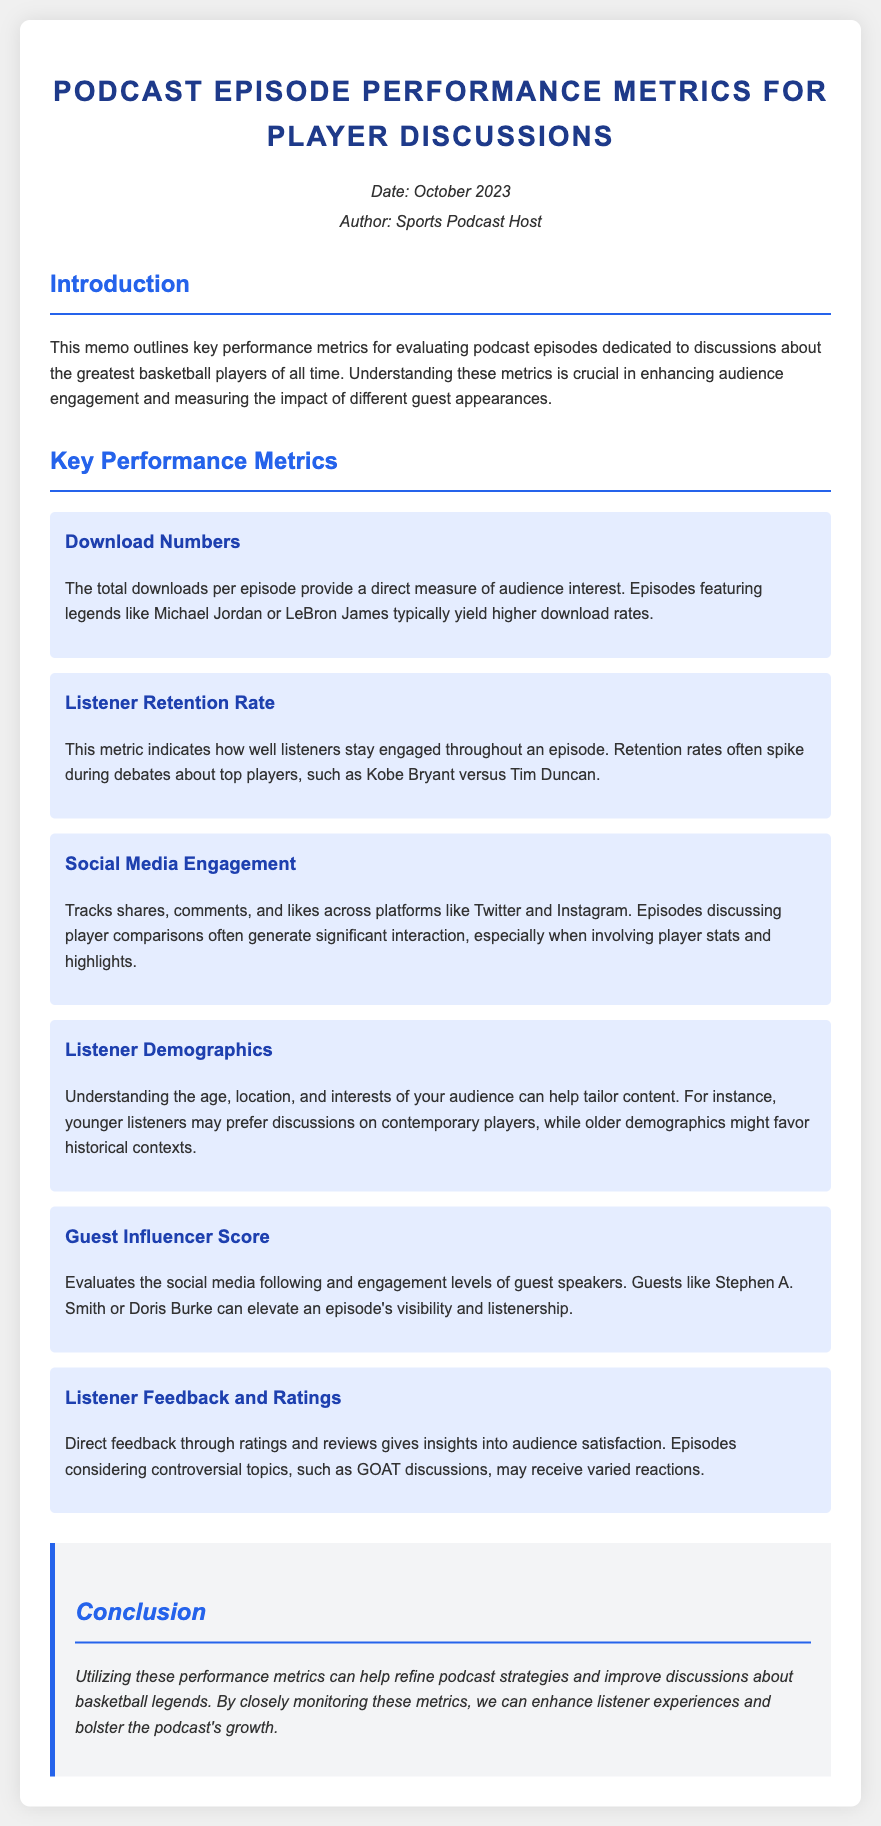What is the date of the memo? The date mentioned in the memo provides the context for the performance metrics evaluation, which is October 2023.
Answer: October 2023 Who is the author of the memo? The author is identified in the header section of the memo, providing credibility to the information shared.
Answer: Sports Podcast Host What is the main focus of the memo? The introduction outlines that the focus is on performance metrics for basketball player discussions, which aids in understanding audience engagement.
Answer: Performance metrics for basketball player discussions Which basketball players are mentioned as examples of high download episodes? Specific player names are used to illustrate successful episodes, highlighting audience interest in iconic figures.
Answer: Michael Jordan or LeBron James What metric indicates listener engagement throughout the episode? This metric is important for assessing how well listeners remain interested, particularly during key segments like debates.
Answer: Listener Retention Rate What does the Guest Influencer Score evaluate? This metric assesses the impact of guests on the visibility and listenership of the episodes.
Answer: Social media following and engagement levels What type of feedback is mentioned as crucial for understanding audience satisfaction? Direct feedback mechanisms help gauge how well the content resonates with listeners, particularly on contentious topics.
Answer: Ratings and reviews In what context do younger listeners prefer discussions? This insight helps tailor content according to audience preferences, especially concerning generational interests in players.
Answer: Contemporary players What is emphasized in the conclusion regarding the use of metrics? The conclusion encapsulates the actionable insights derived from monitoring metrics to enhance content strategy.
Answer: Refine podcast strategies and improve discussions 